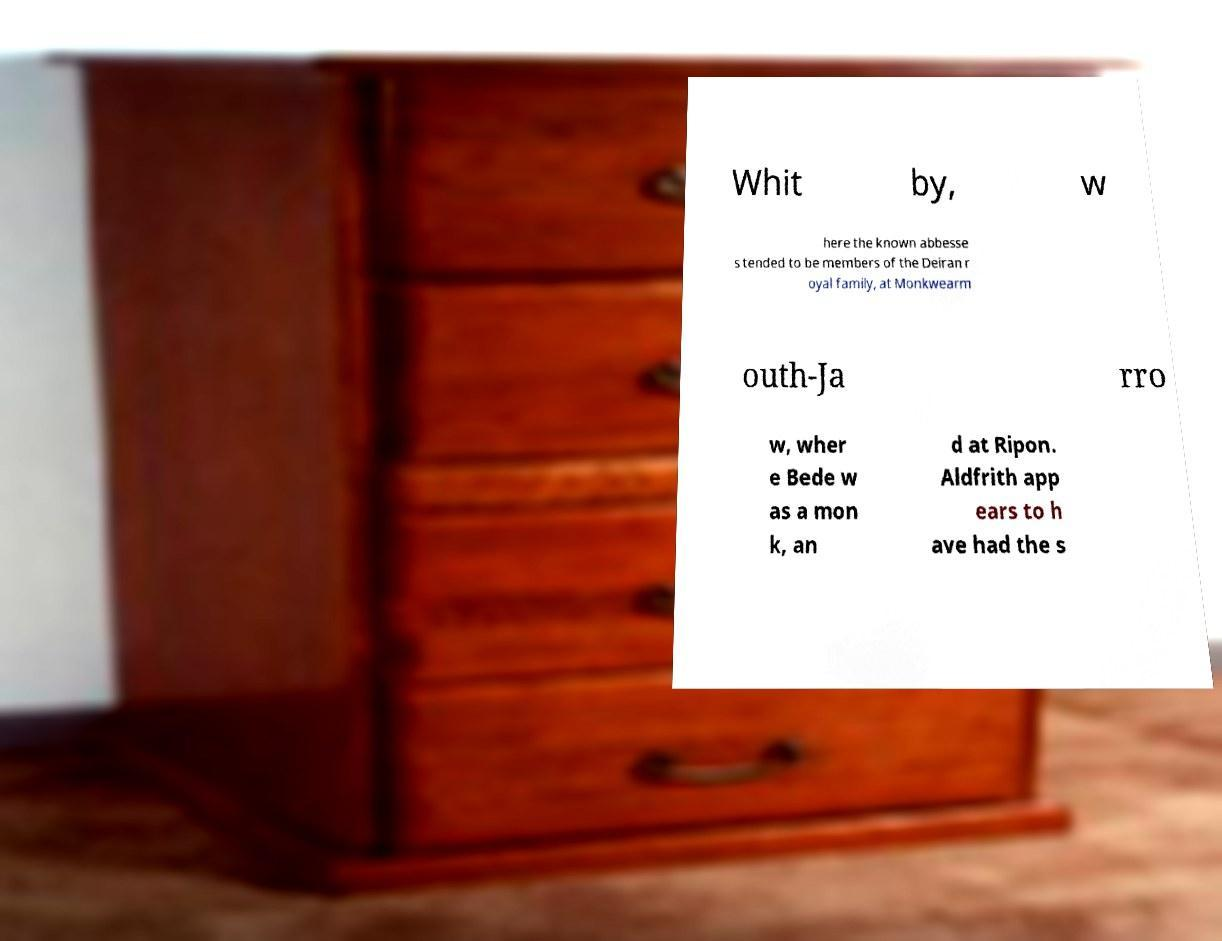Please identify and transcribe the text found in this image. Whit by, w here the known abbesse s tended to be members of the Deiran r oyal family, at Monkwearm outh-Ja rro w, wher e Bede w as a mon k, an d at Ripon. Aldfrith app ears to h ave had the s 